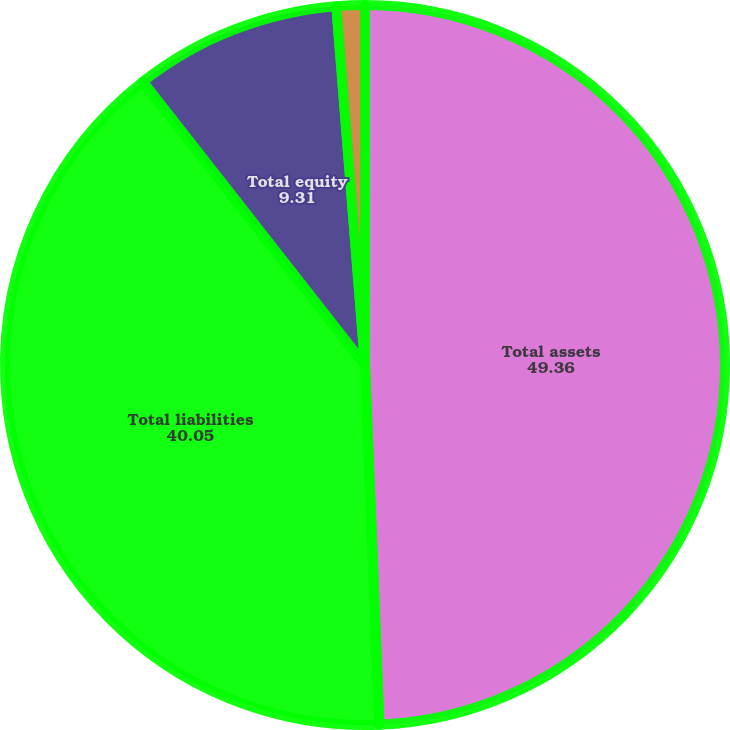Convert chart to OTSL. <chart><loc_0><loc_0><loc_500><loc_500><pie_chart><fcel>Total assets<fcel>Total liabilities<fcel>Total equity<fcel>Net investment in<nl><fcel>49.36%<fcel>40.05%<fcel>9.31%<fcel>1.27%<nl></chart> 